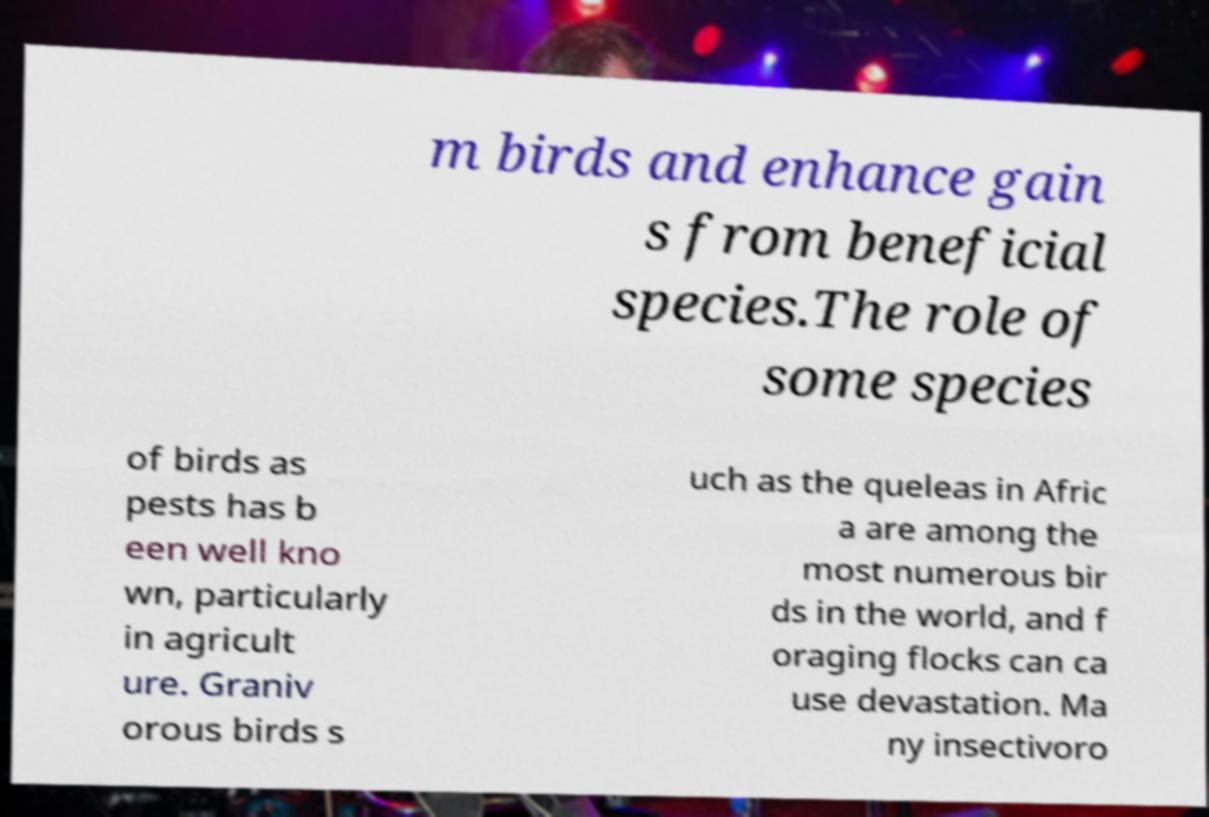Can you read and provide the text displayed in the image?This photo seems to have some interesting text. Can you extract and type it out for me? m birds and enhance gain s from beneficial species.The role of some species of birds as pests has b een well kno wn, particularly in agricult ure. Graniv orous birds s uch as the queleas in Afric a are among the most numerous bir ds in the world, and f oraging flocks can ca use devastation. Ma ny insectivoro 